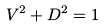<formula> <loc_0><loc_0><loc_500><loc_500>V ^ { 2 } + D ^ { 2 } = 1</formula> 